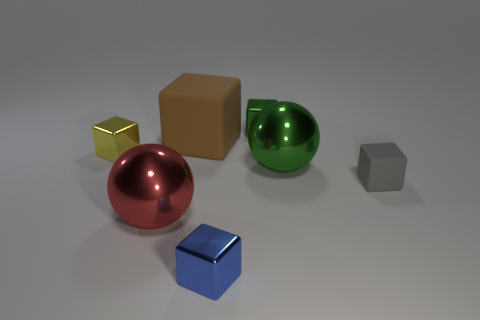What's the texture of the surface on which the objects are placed? The surface appears to have a matte finish with a subtle texture that could suggest a fine grain, possibly similar to a brushed aluminum or a satiny plastic material.  Taking into account the shadows, what can we deduce about the light source in this setting? The shadows cast by the objects are soft and diffuse, indicating that the light source is not extremely close to the objects and could be either a singular broad light source or multiple light sources creating a soft shadow effect. 